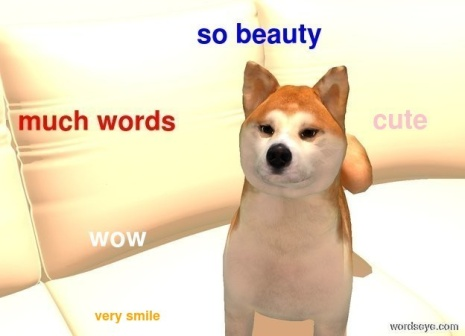Imagine this dog could talk. What would it be saying? If this Shiba Inu could talk, it might say something like, "Hello there, human! Aren't I just the cutest thing you've ever seen? Look at my smile and those words floating around me - they're all about me! So much beauty, such a good smile, wow! Must be amazing to be in my presence, don't you think? Now, how about some treats?" 